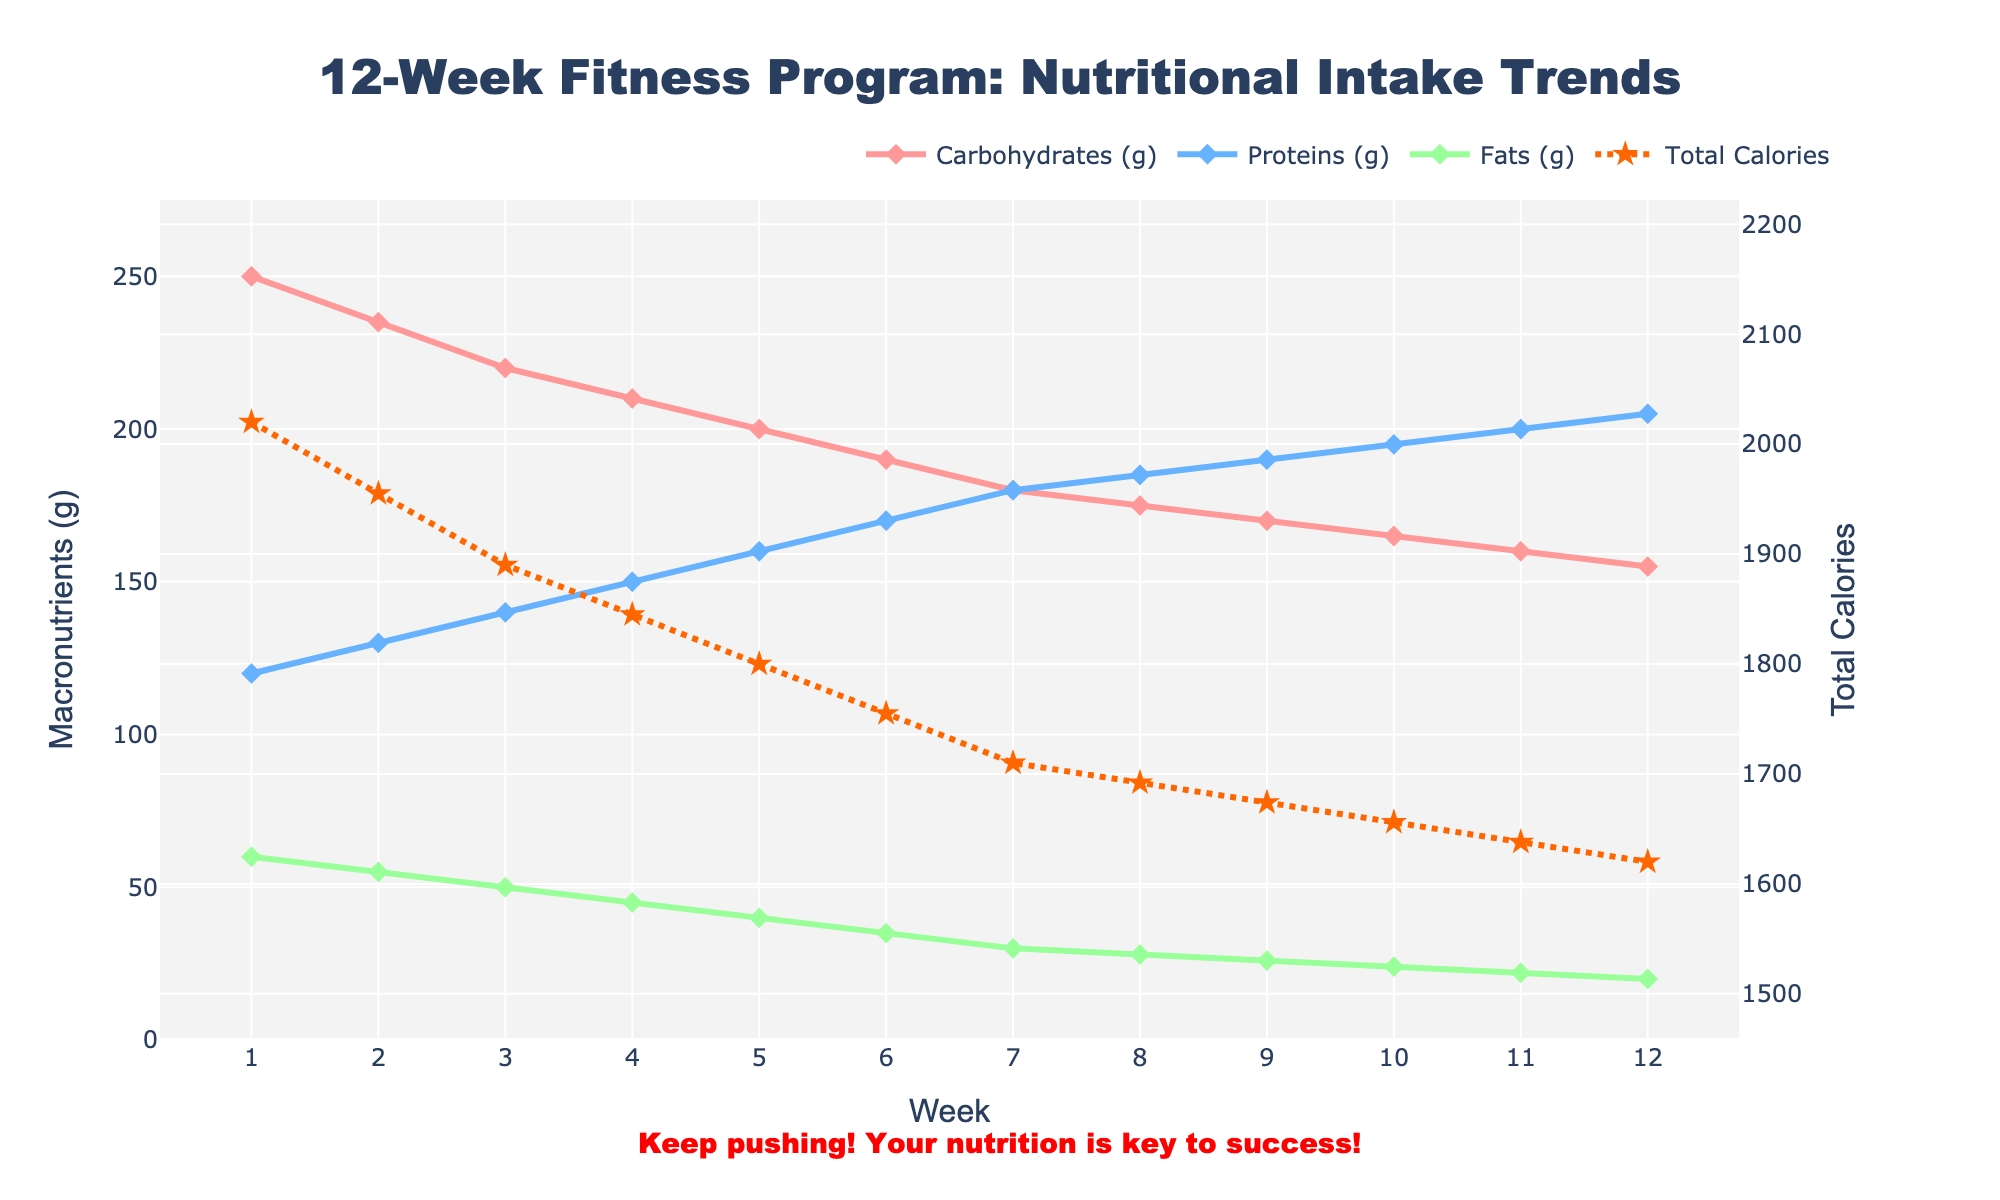What's the trend in total calorie intake over the 12-week period? The total calorie intake decreases nearly every week from Week 1 to Week 12. Starting from 2020 calories in Week 1 and reaching 1620 calories in Week 12.
Answer: Decreasing Between carbohydrates, proteins, and fats, which nutrient shows the steepest decline over the 12 weeks? By examining the lines, carbohydrates show the most significant decline from 250g in Week 1 to 155g in Week 12, which is a total reduction of 95g.
Answer: Carbohydrates Considering the trendlines, how do protein intake levels change compared to carbohydrate and fat intake levels? Protein intake levels consistently increase from 120g in Week 1 to 205g in Week 12, whereas carbohydrate and fat intake levels decrease over the same period.
Answer: Proteins increase, others decrease What's the difference in total calorie intake between Week 1 and Week 12? The total calorie intake in Week 1 is 2020 calories and in Week 12 is 1620 calories. The difference is 2020 - 1620 = 400 calories.
Answer: 400 calories Compare the trend of fats intake from Week 1 to Week 6 with that from Week 7 to Week 12. In the first half (Week 1 to Week 6), fats intake decreases progressively from 60g to 35g. In the second half (Week 7 to Week 12), it continues to decrease but at a slower pace, dropping from 30g to 20g.
Answer: Faster decline in Week 1-6 What is the visual distinction of the total calories trendline compared to macronutrients' trendlines? The total calories trendline is presented with a dotted orange line and star markers, whereas the macronutrients trendlines are in solid lines with diamond markers.
Answer: Dotted orange line with stars Is there any week where protein intake surpasses 190g? If yes, which week(s)? By looking at the protein intake trend, it surpasses 190g starting from Week 10 onwards (Week 10, 11, and 12).
Answer: Week 10, 11, 12 